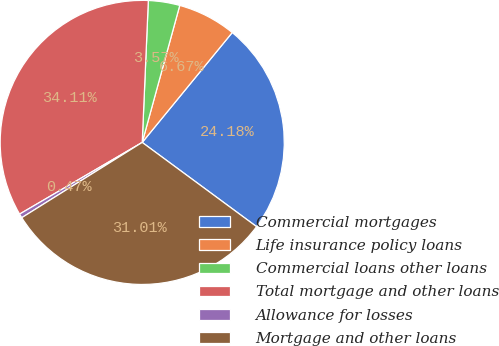Convert chart. <chart><loc_0><loc_0><loc_500><loc_500><pie_chart><fcel>Commercial mortgages<fcel>Life insurance policy loans<fcel>Commercial loans other loans<fcel>Total mortgage and other loans<fcel>Allowance for losses<fcel>Mortgage and other loans<nl><fcel>24.18%<fcel>6.67%<fcel>3.57%<fcel>34.11%<fcel>0.47%<fcel>31.01%<nl></chart> 